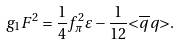<formula> <loc_0><loc_0><loc_500><loc_500>g _ { 1 } F ^ { 2 } = \frac { 1 } { 4 } f _ { \pi } ^ { 2 } \varepsilon - \frac { 1 } { 1 2 } { < } \overline { q } q { > } .</formula> 